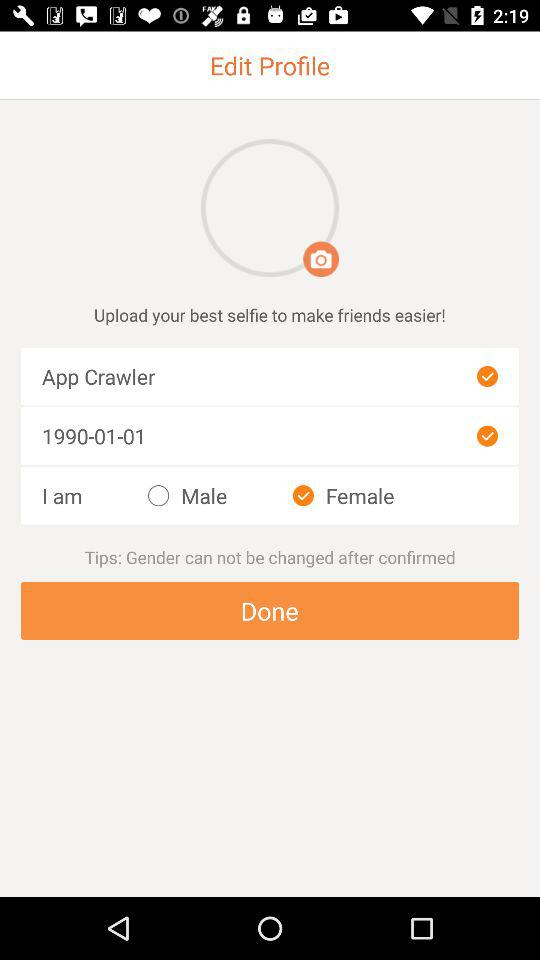What is the name of the user? The name of the user is App Crawler. 